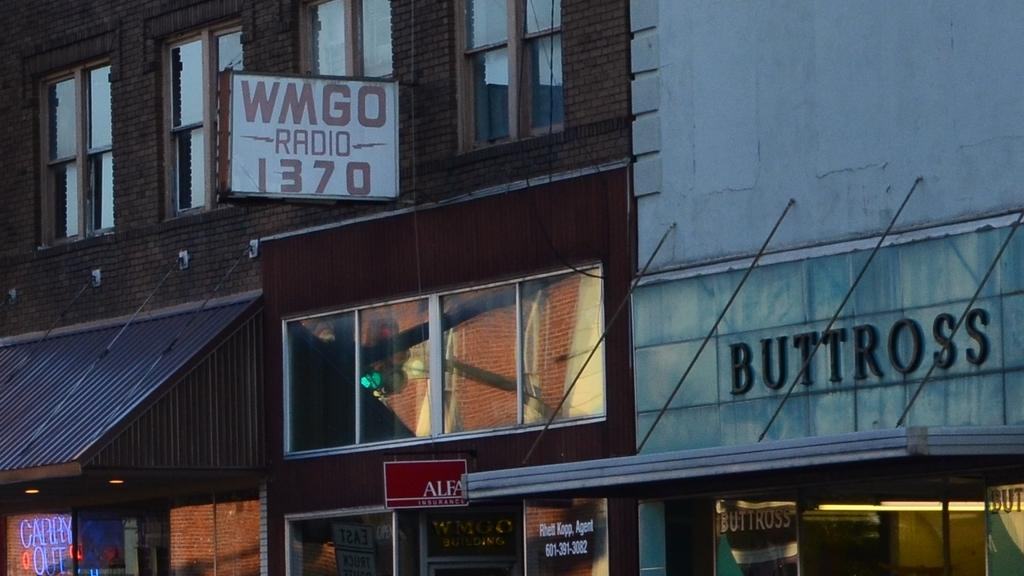What type of structures can be seen in the image? There are buildings in the image. What architectural features are visible on the buildings? There are windows and glass doors in the image. Can you describe any signage or text in the image? There is a name board on a wall and text written on a wall in the image. Are there any lighting fixtures visible in the image? Yes, there are lights in the image. What other objects can be seen in the image besides the buildings and lights? There are boards and other objects in the image. What type of cheese is being served on the ship in the image? There is no cheese or ship present in the image; it features buildings, windows, a name board, text, lights, boards, and other objects. 